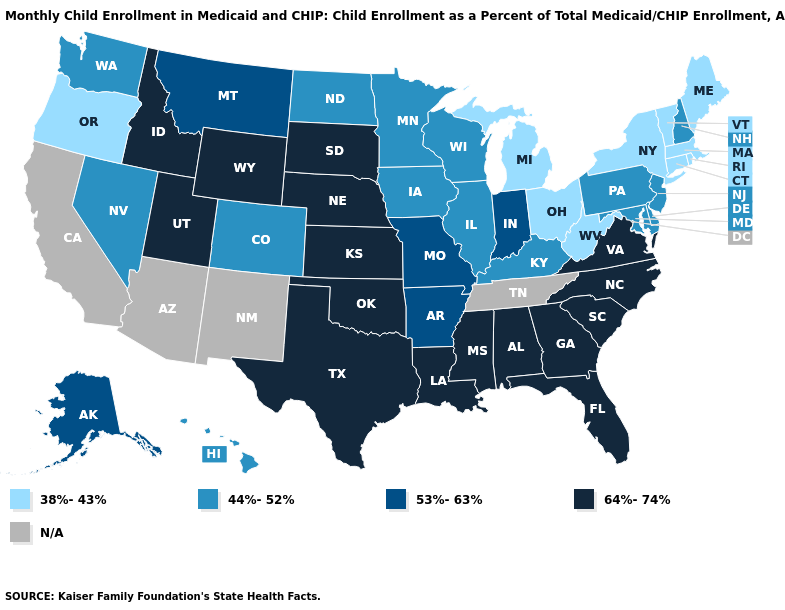Does South Dakota have the highest value in the MidWest?
Give a very brief answer. Yes. Is the legend a continuous bar?
Quick response, please. No. Does the first symbol in the legend represent the smallest category?
Short answer required. Yes. How many symbols are there in the legend?
Short answer required. 5. Does Hawaii have the highest value in the West?
Answer briefly. No. Which states have the lowest value in the USA?
Write a very short answer. Connecticut, Maine, Massachusetts, Michigan, New York, Ohio, Oregon, Rhode Island, Vermont, West Virginia. Which states have the highest value in the USA?
Keep it brief. Alabama, Florida, Georgia, Idaho, Kansas, Louisiana, Mississippi, Nebraska, North Carolina, Oklahoma, South Carolina, South Dakota, Texas, Utah, Virginia, Wyoming. Name the states that have a value in the range 53%-63%?
Write a very short answer. Alaska, Arkansas, Indiana, Missouri, Montana. Name the states that have a value in the range N/A?
Concise answer only. Arizona, California, New Mexico, Tennessee. Name the states that have a value in the range 53%-63%?
Be succinct. Alaska, Arkansas, Indiana, Missouri, Montana. What is the value of Montana?
Short answer required. 53%-63%. Which states have the lowest value in the USA?
Quick response, please. Connecticut, Maine, Massachusetts, Michigan, New York, Ohio, Oregon, Rhode Island, Vermont, West Virginia. Name the states that have a value in the range N/A?
Give a very brief answer. Arizona, California, New Mexico, Tennessee. Which states hav the highest value in the West?
Concise answer only. Idaho, Utah, Wyoming. Does Nebraska have the lowest value in the USA?
Be succinct. No. 